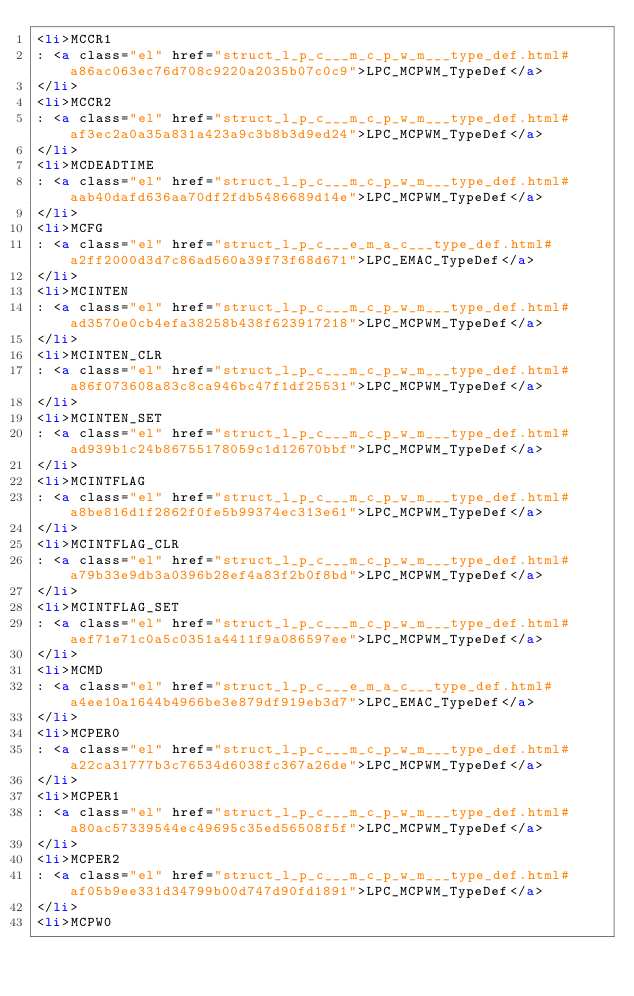Convert code to text. <code><loc_0><loc_0><loc_500><loc_500><_HTML_><li>MCCR1
: <a class="el" href="struct_l_p_c___m_c_p_w_m___type_def.html#a86ac063ec76d708c9220a2035b07c0c9">LPC_MCPWM_TypeDef</a>
</li>
<li>MCCR2
: <a class="el" href="struct_l_p_c___m_c_p_w_m___type_def.html#af3ec2a0a35a831a423a9c3b8b3d9ed24">LPC_MCPWM_TypeDef</a>
</li>
<li>MCDEADTIME
: <a class="el" href="struct_l_p_c___m_c_p_w_m___type_def.html#aab40dafd636aa70df2fdb5486689d14e">LPC_MCPWM_TypeDef</a>
</li>
<li>MCFG
: <a class="el" href="struct_l_p_c___e_m_a_c___type_def.html#a2ff2000d3d7c86ad560a39f73f68d671">LPC_EMAC_TypeDef</a>
</li>
<li>MCINTEN
: <a class="el" href="struct_l_p_c___m_c_p_w_m___type_def.html#ad3570e0cb4efa38258b438f623917218">LPC_MCPWM_TypeDef</a>
</li>
<li>MCINTEN_CLR
: <a class="el" href="struct_l_p_c___m_c_p_w_m___type_def.html#a86f073608a83c8ca946bc47f1df25531">LPC_MCPWM_TypeDef</a>
</li>
<li>MCINTEN_SET
: <a class="el" href="struct_l_p_c___m_c_p_w_m___type_def.html#ad939b1c24b86755178059c1d12670bbf">LPC_MCPWM_TypeDef</a>
</li>
<li>MCINTFLAG
: <a class="el" href="struct_l_p_c___m_c_p_w_m___type_def.html#a8be816d1f2862f0fe5b99374ec313e61">LPC_MCPWM_TypeDef</a>
</li>
<li>MCINTFLAG_CLR
: <a class="el" href="struct_l_p_c___m_c_p_w_m___type_def.html#a79b33e9db3a0396b28ef4a83f2b0f8bd">LPC_MCPWM_TypeDef</a>
</li>
<li>MCINTFLAG_SET
: <a class="el" href="struct_l_p_c___m_c_p_w_m___type_def.html#aef71e71c0a5c0351a4411f9a086597ee">LPC_MCPWM_TypeDef</a>
</li>
<li>MCMD
: <a class="el" href="struct_l_p_c___e_m_a_c___type_def.html#a4ee10a1644b4966be3e879df919eb3d7">LPC_EMAC_TypeDef</a>
</li>
<li>MCPER0
: <a class="el" href="struct_l_p_c___m_c_p_w_m___type_def.html#a22ca31777b3c76534d6038fc367a26de">LPC_MCPWM_TypeDef</a>
</li>
<li>MCPER1
: <a class="el" href="struct_l_p_c___m_c_p_w_m___type_def.html#a80ac57339544ec49695c35ed56508f5f">LPC_MCPWM_TypeDef</a>
</li>
<li>MCPER2
: <a class="el" href="struct_l_p_c___m_c_p_w_m___type_def.html#af05b9ee331d34799b00d747d90fd1891">LPC_MCPWM_TypeDef</a>
</li>
<li>MCPW0</code> 